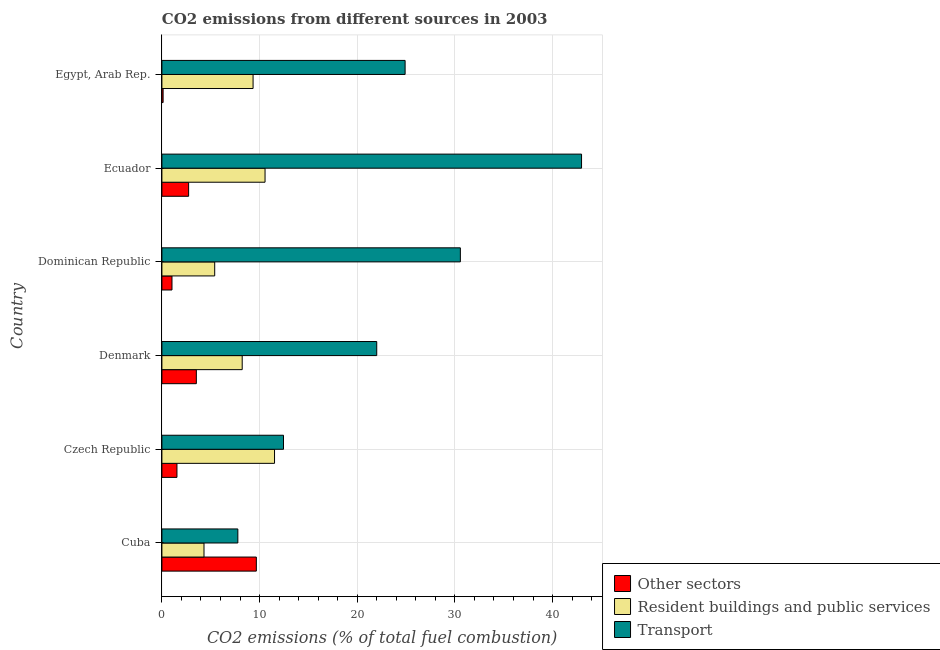How many different coloured bars are there?
Give a very brief answer. 3. Are the number of bars per tick equal to the number of legend labels?
Offer a terse response. Yes. Are the number of bars on each tick of the Y-axis equal?
Keep it short and to the point. Yes. How many bars are there on the 1st tick from the top?
Make the answer very short. 3. What is the label of the 2nd group of bars from the top?
Provide a short and direct response. Ecuador. In how many cases, is the number of bars for a given country not equal to the number of legend labels?
Provide a succinct answer. 0. What is the percentage of co2 emissions from transport in Cuba?
Keep it short and to the point. 7.78. Across all countries, what is the maximum percentage of co2 emissions from other sectors?
Offer a very short reply. 9.67. Across all countries, what is the minimum percentage of co2 emissions from other sectors?
Your answer should be compact. 0.12. In which country was the percentage of co2 emissions from resident buildings and public services maximum?
Your answer should be compact. Czech Republic. In which country was the percentage of co2 emissions from resident buildings and public services minimum?
Give a very brief answer. Cuba. What is the total percentage of co2 emissions from transport in the graph?
Ensure brevity in your answer.  140.65. What is the difference between the percentage of co2 emissions from resident buildings and public services in Czech Republic and that in Dominican Republic?
Keep it short and to the point. 6.12. What is the difference between the percentage of co2 emissions from resident buildings and public services in Czech Republic and the percentage of co2 emissions from other sectors in Cuba?
Offer a terse response. 1.86. What is the average percentage of co2 emissions from resident buildings and public services per country?
Your answer should be very brief. 8.23. What is the difference between the percentage of co2 emissions from resident buildings and public services and percentage of co2 emissions from transport in Cuba?
Provide a succinct answer. -3.46. In how many countries, is the percentage of co2 emissions from transport greater than 36 %?
Offer a terse response. 1. What is the ratio of the percentage of co2 emissions from transport in Czech Republic to that in Ecuador?
Your answer should be compact. 0.29. Is the percentage of co2 emissions from transport in Cuba less than that in Egypt, Arab Rep.?
Your response must be concise. Yes. What is the difference between the highest and the lowest percentage of co2 emissions from transport?
Keep it short and to the point. 35.19. In how many countries, is the percentage of co2 emissions from transport greater than the average percentage of co2 emissions from transport taken over all countries?
Make the answer very short. 3. Is the sum of the percentage of co2 emissions from transport in Denmark and Egypt, Arab Rep. greater than the maximum percentage of co2 emissions from resident buildings and public services across all countries?
Your response must be concise. Yes. What does the 1st bar from the top in Ecuador represents?
Make the answer very short. Transport. What does the 3rd bar from the bottom in Egypt, Arab Rep. represents?
Keep it short and to the point. Transport. Is it the case that in every country, the sum of the percentage of co2 emissions from other sectors and percentage of co2 emissions from resident buildings and public services is greater than the percentage of co2 emissions from transport?
Make the answer very short. No. Are all the bars in the graph horizontal?
Your answer should be very brief. Yes. How many countries are there in the graph?
Your answer should be compact. 6. Are the values on the major ticks of X-axis written in scientific E-notation?
Offer a very short reply. No. Does the graph contain any zero values?
Keep it short and to the point. No. Where does the legend appear in the graph?
Offer a terse response. Bottom right. How many legend labels are there?
Provide a short and direct response. 3. How are the legend labels stacked?
Offer a terse response. Vertical. What is the title of the graph?
Provide a short and direct response. CO2 emissions from different sources in 2003. What is the label or title of the X-axis?
Make the answer very short. CO2 emissions (% of total fuel combustion). What is the label or title of the Y-axis?
Provide a succinct answer. Country. What is the CO2 emissions (% of total fuel combustion) of Other sectors in Cuba?
Provide a short and direct response. 9.67. What is the CO2 emissions (% of total fuel combustion) of Resident buildings and public services in Cuba?
Ensure brevity in your answer.  4.31. What is the CO2 emissions (% of total fuel combustion) in Transport in Cuba?
Offer a terse response. 7.78. What is the CO2 emissions (% of total fuel combustion) of Other sectors in Czech Republic?
Provide a succinct answer. 1.54. What is the CO2 emissions (% of total fuel combustion) in Resident buildings and public services in Czech Republic?
Provide a short and direct response. 11.53. What is the CO2 emissions (% of total fuel combustion) in Transport in Czech Republic?
Make the answer very short. 12.45. What is the CO2 emissions (% of total fuel combustion) of Other sectors in Denmark?
Your response must be concise. 3.53. What is the CO2 emissions (% of total fuel combustion) of Resident buildings and public services in Denmark?
Provide a short and direct response. 8.22. What is the CO2 emissions (% of total fuel combustion) in Transport in Denmark?
Ensure brevity in your answer.  22. What is the CO2 emissions (% of total fuel combustion) in Other sectors in Dominican Republic?
Ensure brevity in your answer.  1.03. What is the CO2 emissions (% of total fuel combustion) in Resident buildings and public services in Dominican Republic?
Offer a very short reply. 5.41. What is the CO2 emissions (% of total fuel combustion) in Transport in Dominican Republic?
Your answer should be compact. 30.56. What is the CO2 emissions (% of total fuel combustion) in Other sectors in Ecuador?
Provide a succinct answer. 2.74. What is the CO2 emissions (% of total fuel combustion) in Resident buildings and public services in Ecuador?
Ensure brevity in your answer.  10.56. What is the CO2 emissions (% of total fuel combustion) in Transport in Ecuador?
Provide a succinct answer. 42.97. What is the CO2 emissions (% of total fuel combustion) in Other sectors in Egypt, Arab Rep.?
Offer a terse response. 0.12. What is the CO2 emissions (% of total fuel combustion) of Resident buildings and public services in Egypt, Arab Rep.?
Your answer should be compact. 9.33. What is the CO2 emissions (% of total fuel combustion) of Transport in Egypt, Arab Rep.?
Ensure brevity in your answer.  24.9. Across all countries, what is the maximum CO2 emissions (% of total fuel combustion) in Other sectors?
Provide a short and direct response. 9.67. Across all countries, what is the maximum CO2 emissions (% of total fuel combustion) in Resident buildings and public services?
Provide a short and direct response. 11.53. Across all countries, what is the maximum CO2 emissions (% of total fuel combustion) of Transport?
Your answer should be very brief. 42.97. Across all countries, what is the minimum CO2 emissions (% of total fuel combustion) in Other sectors?
Provide a short and direct response. 0.12. Across all countries, what is the minimum CO2 emissions (% of total fuel combustion) of Resident buildings and public services?
Your answer should be compact. 4.31. Across all countries, what is the minimum CO2 emissions (% of total fuel combustion) of Transport?
Make the answer very short. 7.78. What is the total CO2 emissions (% of total fuel combustion) of Other sectors in the graph?
Your answer should be compact. 18.63. What is the total CO2 emissions (% of total fuel combustion) of Resident buildings and public services in the graph?
Your answer should be compact. 49.37. What is the total CO2 emissions (% of total fuel combustion) of Transport in the graph?
Ensure brevity in your answer.  140.65. What is the difference between the CO2 emissions (% of total fuel combustion) in Other sectors in Cuba and that in Czech Republic?
Ensure brevity in your answer.  8.13. What is the difference between the CO2 emissions (% of total fuel combustion) of Resident buildings and public services in Cuba and that in Czech Republic?
Offer a terse response. -7.22. What is the difference between the CO2 emissions (% of total fuel combustion) of Transport in Cuba and that in Czech Republic?
Your answer should be compact. -4.67. What is the difference between the CO2 emissions (% of total fuel combustion) in Other sectors in Cuba and that in Denmark?
Give a very brief answer. 6.14. What is the difference between the CO2 emissions (% of total fuel combustion) in Resident buildings and public services in Cuba and that in Denmark?
Offer a terse response. -3.91. What is the difference between the CO2 emissions (% of total fuel combustion) in Transport in Cuba and that in Denmark?
Ensure brevity in your answer.  -14.22. What is the difference between the CO2 emissions (% of total fuel combustion) of Other sectors in Cuba and that in Dominican Republic?
Your response must be concise. 8.64. What is the difference between the CO2 emissions (% of total fuel combustion) in Resident buildings and public services in Cuba and that in Dominican Republic?
Provide a short and direct response. -1.1. What is the difference between the CO2 emissions (% of total fuel combustion) in Transport in Cuba and that in Dominican Republic?
Offer a terse response. -22.78. What is the difference between the CO2 emissions (% of total fuel combustion) of Other sectors in Cuba and that in Ecuador?
Keep it short and to the point. 6.93. What is the difference between the CO2 emissions (% of total fuel combustion) in Resident buildings and public services in Cuba and that in Ecuador?
Offer a very short reply. -6.25. What is the difference between the CO2 emissions (% of total fuel combustion) of Transport in Cuba and that in Ecuador?
Make the answer very short. -35.19. What is the difference between the CO2 emissions (% of total fuel combustion) in Other sectors in Cuba and that in Egypt, Arab Rep.?
Your answer should be compact. 9.55. What is the difference between the CO2 emissions (% of total fuel combustion) of Resident buildings and public services in Cuba and that in Egypt, Arab Rep.?
Provide a short and direct response. -5.02. What is the difference between the CO2 emissions (% of total fuel combustion) in Transport in Cuba and that in Egypt, Arab Rep.?
Give a very brief answer. -17.13. What is the difference between the CO2 emissions (% of total fuel combustion) of Other sectors in Czech Republic and that in Denmark?
Give a very brief answer. -1.99. What is the difference between the CO2 emissions (% of total fuel combustion) in Resident buildings and public services in Czech Republic and that in Denmark?
Your answer should be very brief. 3.31. What is the difference between the CO2 emissions (% of total fuel combustion) of Transport in Czech Republic and that in Denmark?
Ensure brevity in your answer.  -9.55. What is the difference between the CO2 emissions (% of total fuel combustion) of Other sectors in Czech Republic and that in Dominican Republic?
Provide a short and direct response. 0.51. What is the difference between the CO2 emissions (% of total fuel combustion) of Resident buildings and public services in Czech Republic and that in Dominican Republic?
Give a very brief answer. 6.12. What is the difference between the CO2 emissions (% of total fuel combustion) of Transport in Czech Republic and that in Dominican Republic?
Your answer should be compact. -18.11. What is the difference between the CO2 emissions (% of total fuel combustion) in Other sectors in Czech Republic and that in Ecuador?
Ensure brevity in your answer.  -1.2. What is the difference between the CO2 emissions (% of total fuel combustion) in Resident buildings and public services in Czech Republic and that in Ecuador?
Keep it short and to the point. 0.97. What is the difference between the CO2 emissions (% of total fuel combustion) of Transport in Czech Republic and that in Ecuador?
Make the answer very short. -30.52. What is the difference between the CO2 emissions (% of total fuel combustion) of Other sectors in Czech Republic and that in Egypt, Arab Rep.?
Keep it short and to the point. 1.42. What is the difference between the CO2 emissions (% of total fuel combustion) in Resident buildings and public services in Czech Republic and that in Egypt, Arab Rep.?
Give a very brief answer. 2.2. What is the difference between the CO2 emissions (% of total fuel combustion) in Transport in Czech Republic and that in Egypt, Arab Rep.?
Offer a very short reply. -12.45. What is the difference between the CO2 emissions (% of total fuel combustion) of Other sectors in Denmark and that in Dominican Republic?
Your answer should be compact. 2.49. What is the difference between the CO2 emissions (% of total fuel combustion) of Resident buildings and public services in Denmark and that in Dominican Republic?
Give a very brief answer. 2.82. What is the difference between the CO2 emissions (% of total fuel combustion) in Transport in Denmark and that in Dominican Republic?
Keep it short and to the point. -8.56. What is the difference between the CO2 emissions (% of total fuel combustion) of Other sectors in Denmark and that in Ecuador?
Ensure brevity in your answer.  0.79. What is the difference between the CO2 emissions (% of total fuel combustion) of Resident buildings and public services in Denmark and that in Ecuador?
Offer a very short reply. -2.34. What is the difference between the CO2 emissions (% of total fuel combustion) in Transport in Denmark and that in Ecuador?
Your answer should be very brief. -20.97. What is the difference between the CO2 emissions (% of total fuel combustion) in Other sectors in Denmark and that in Egypt, Arab Rep.?
Your answer should be very brief. 3.4. What is the difference between the CO2 emissions (% of total fuel combustion) of Resident buildings and public services in Denmark and that in Egypt, Arab Rep.?
Offer a very short reply. -1.11. What is the difference between the CO2 emissions (% of total fuel combustion) of Transport in Denmark and that in Egypt, Arab Rep.?
Offer a very short reply. -2.9. What is the difference between the CO2 emissions (% of total fuel combustion) in Other sectors in Dominican Republic and that in Ecuador?
Your answer should be very brief. -1.7. What is the difference between the CO2 emissions (% of total fuel combustion) of Resident buildings and public services in Dominican Republic and that in Ecuador?
Your response must be concise. -5.15. What is the difference between the CO2 emissions (% of total fuel combustion) of Transport in Dominican Republic and that in Ecuador?
Offer a very short reply. -12.41. What is the difference between the CO2 emissions (% of total fuel combustion) of Other sectors in Dominican Republic and that in Egypt, Arab Rep.?
Your answer should be very brief. 0.91. What is the difference between the CO2 emissions (% of total fuel combustion) in Resident buildings and public services in Dominican Republic and that in Egypt, Arab Rep.?
Your response must be concise. -3.93. What is the difference between the CO2 emissions (% of total fuel combustion) of Transport in Dominican Republic and that in Egypt, Arab Rep.?
Your answer should be very brief. 5.66. What is the difference between the CO2 emissions (% of total fuel combustion) of Other sectors in Ecuador and that in Egypt, Arab Rep.?
Make the answer very short. 2.61. What is the difference between the CO2 emissions (% of total fuel combustion) in Resident buildings and public services in Ecuador and that in Egypt, Arab Rep.?
Provide a succinct answer. 1.23. What is the difference between the CO2 emissions (% of total fuel combustion) of Transport in Ecuador and that in Egypt, Arab Rep.?
Give a very brief answer. 18.07. What is the difference between the CO2 emissions (% of total fuel combustion) in Other sectors in Cuba and the CO2 emissions (% of total fuel combustion) in Resident buildings and public services in Czech Republic?
Your response must be concise. -1.86. What is the difference between the CO2 emissions (% of total fuel combustion) in Other sectors in Cuba and the CO2 emissions (% of total fuel combustion) in Transport in Czech Republic?
Provide a short and direct response. -2.78. What is the difference between the CO2 emissions (% of total fuel combustion) of Resident buildings and public services in Cuba and the CO2 emissions (% of total fuel combustion) of Transport in Czech Republic?
Your answer should be very brief. -8.14. What is the difference between the CO2 emissions (% of total fuel combustion) in Other sectors in Cuba and the CO2 emissions (% of total fuel combustion) in Resident buildings and public services in Denmark?
Your response must be concise. 1.45. What is the difference between the CO2 emissions (% of total fuel combustion) in Other sectors in Cuba and the CO2 emissions (% of total fuel combustion) in Transport in Denmark?
Make the answer very short. -12.33. What is the difference between the CO2 emissions (% of total fuel combustion) in Resident buildings and public services in Cuba and the CO2 emissions (% of total fuel combustion) in Transport in Denmark?
Your answer should be very brief. -17.69. What is the difference between the CO2 emissions (% of total fuel combustion) of Other sectors in Cuba and the CO2 emissions (% of total fuel combustion) of Resident buildings and public services in Dominican Republic?
Provide a succinct answer. 4.26. What is the difference between the CO2 emissions (% of total fuel combustion) in Other sectors in Cuba and the CO2 emissions (% of total fuel combustion) in Transport in Dominican Republic?
Provide a succinct answer. -20.89. What is the difference between the CO2 emissions (% of total fuel combustion) of Resident buildings and public services in Cuba and the CO2 emissions (% of total fuel combustion) of Transport in Dominican Republic?
Provide a short and direct response. -26.25. What is the difference between the CO2 emissions (% of total fuel combustion) in Other sectors in Cuba and the CO2 emissions (% of total fuel combustion) in Resident buildings and public services in Ecuador?
Offer a terse response. -0.89. What is the difference between the CO2 emissions (% of total fuel combustion) of Other sectors in Cuba and the CO2 emissions (% of total fuel combustion) of Transport in Ecuador?
Keep it short and to the point. -33.3. What is the difference between the CO2 emissions (% of total fuel combustion) in Resident buildings and public services in Cuba and the CO2 emissions (% of total fuel combustion) in Transport in Ecuador?
Your response must be concise. -38.66. What is the difference between the CO2 emissions (% of total fuel combustion) of Other sectors in Cuba and the CO2 emissions (% of total fuel combustion) of Resident buildings and public services in Egypt, Arab Rep.?
Make the answer very short. 0.33. What is the difference between the CO2 emissions (% of total fuel combustion) in Other sectors in Cuba and the CO2 emissions (% of total fuel combustion) in Transport in Egypt, Arab Rep.?
Provide a succinct answer. -15.23. What is the difference between the CO2 emissions (% of total fuel combustion) of Resident buildings and public services in Cuba and the CO2 emissions (% of total fuel combustion) of Transport in Egypt, Arab Rep.?
Ensure brevity in your answer.  -20.59. What is the difference between the CO2 emissions (% of total fuel combustion) in Other sectors in Czech Republic and the CO2 emissions (% of total fuel combustion) in Resident buildings and public services in Denmark?
Provide a short and direct response. -6.68. What is the difference between the CO2 emissions (% of total fuel combustion) of Other sectors in Czech Republic and the CO2 emissions (% of total fuel combustion) of Transport in Denmark?
Your answer should be very brief. -20.46. What is the difference between the CO2 emissions (% of total fuel combustion) of Resident buildings and public services in Czech Republic and the CO2 emissions (% of total fuel combustion) of Transport in Denmark?
Your answer should be very brief. -10.47. What is the difference between the CO2 emissions (% of total fuel combustion) in Other sectors in Czech Republic and the CO2 emissions (% of total fuel combustion) in Resident buildings and public services in Dominican Republic?
Your answer should be very brief. -3.87. What is the difference between the CO2 emissions (% of total fuel combustion) of Other sectors in Czech Republic and the CO2 emissions (% of total fuel combustion) of Transport in Dominican Republic?
Provide a short and direct response. -29.02. What is the difference between the CO2 emissions (% of total fuel combustion) in Resident buildings and public services in Czech Republic and the CO2 emissions (% of total fuel combustion) in Transport in Dominican Republic?
Keep it short and to the point. -19.03. What is the difference between the CO2 emissions (% of total fuel combustion) in Other sectors in Czech Republic and the CO2 emissions (% of total fuel combustion) in Resident buildings and public services in Ecuador?
Offer a terse response. -9.02. What is the difference between the CO2 emissions (% of total fuel combustion) in Other sectors in Czech Republic and the CO2 emissions (% of total fuel combustion) in Transport in Ecuador?
Make the answer very short. -41.43. What is the difference between the CO2 emissions (% of total fuel combustion) in Resident buildings and public services in Czech Republic and the CO2 emissions (% of total fuel combustion) in Transport in Ecuador?
Offer a very short reply. -31.43. What is the difference between the CO2 emissions (% of total fuel combustion) in Other sectors in Czech Republic and the CO2 emissions (% of total fuel combustion) in Resident buildings and public services in Egypt, Arab Rep.?
Your response must be concise. -7.79. What is the difference between the CO2 emissions (% of total fuel combustion) of Other sectors in Czech Republic and the CO2 emissions (% of total fuel combustion) of Transport in Egypt, Arab Rep.?
Your answer should be very brief. -23.36. What is the difference between the CO2 emissions (% of total fuel combustion) of Resident buildings and public services in Czech Republic and the CO2 emissions (% of total fuel combustion) of Transport in Egypt, Arab Rep.?
Your answer should be compact. -13.37. What is the difference between the CO2 emissions (% of total fuel combustion) in Other sectors in Denmark and the CO2 emissions (% of total fuel combustion) in Resident buildings and public services in Dominican Republic?
Ensure brevity in your answer.  -1.88. What is the difference between the CO2 emissions (% of total fuel combustion) of Other sectors in Denmark and the CO2 emissions (% of total fuel combustion) of Transport in Dominican Republic?
Make the answer very short. -27.03. What is the difference between the CO2 emissions (% of total fuel combustion) in Resident buildings and public services in Denmark and the CO2 emissions (% of total fuel combustion) in Transport in Dominican Republic?
Provide a succinct answer. -22.34. What is the difference between the CO2 emissions (% of total fuel combustion) of Other sectors in Denmark and the CO2 emissions (% of total fuel combustion) of Resident buildings and public services in Ecuador?
Your answer should be compact. -7.04. What is the difference between the CO2 emissions (% of total fuel combustion) in Other sectors in Denmark and the CO2 emissions (% of total fuel combustion) in Transport in Ecuador?
Offer a very short reply. -39.44. What is the difference between the CO2 emissions (% of total fuel combustion) in Resident buildings and public services in Denmark and the CO2 emissions (% of total fuel combustion) in Transport in Ecuador?
Provide a short and direct response. -34.74. What is the difference between the CO2 emissions (% of total fuel combustion) in Other sectors in Denmark and the CO2 emissions (% of total fuel combustion) in Resident buildings and public services in Egypt, Arab Rep.?
Offer a terse response. -5.81. What is the difference between the CO2 emissions (% of total fuel combustion) of Other sectors in Denmark and the CO2 emissions (% of total fuel combustion) of Transport in Egypt, Arab Rep.?
Offer a terse response. -21.37. What is the difference between the CO2 emissions (% of total fuel combustion) in Resident buildings and public services in Denmark and the CO2 emissions (% of total fuel combustion) in Transport in Egypt, Arab Rep.?
Make the answer very short. -16.68. What is the difference between the CO2 emissions (% of total fuel combustion) in Other sectors in Dominican Republic and the CO2 emissions (% of total fuel combustion) in Resident buildings and public services in Ecuador?
Your response must be concise. -9.53. What is the difference between the CO2 emissions (% of total fuel combustion) of Other sectors in Dominican Republic and the CO2 emissions (% of total fuel combustion) of Transport in Ecuador?
Keep it short and to the point. -41.93. What is the difference between the CO2 emissions (% of total fuel combustion) in Resident buildings and public services in Dominican Republic and the CO2 emissions (% of total fuel combustion) in Transport in Ecuador?
Provide a succinct answer. -37.56. What is the difference between the CO2 emissions (% of total fuel combustion) of Other sectors in Dominican Republic and the CO2 emissions (% of total fuel combustion) of Resident buildings and public services in Egypt, Arab Rep.?
Provide a short and direct response. -8.3. What is the difference between the CO2 emissions (% of total fuel combustion) of Other sectors in Dominican Republic and the CO2 emissions (% of total fuel combustion) of Transport in Egypt, Arab Rep.?
Provide a succinct answer. -23.87. What is the difference between the CO2 emissions (% of total fuel combustion) of Resident buildings and public services in Dominican Republic and the CO2 emissions (% of total fuel combustion) of Transport in Egypt, Arab Rep.?
Offer a terse response. -19.49. What is the difference between the CO2 emissions (% of total fuel combustion) of Other sectors in Ecuador and the CO2 emissions (% of total fuel combustion) of Resident buildings and public services in Egypt, Arab Rep.?
Your answer should be very brief. -6.6. What is the difference between the CO2 emissions (% of total fuel combustion) in Other sectors in Ecuador and the CO2 emissions (% of total fuel combustion) in Transport in Egypt, Arab Rep.?
Offer a very short reply. -22.16. What is the difference between the CO2 emissions (% of total fuel combustion) of Resident buildings and public services in Ecuador and the CO2 emissions (% of total fuel combustion) of Transport in Egypt, Arab Rep.?
Your answer should be very brief. -14.34. What is the average CO2 emissions (% of total fuel combustion) of Other sectors per country?
Provide a short and direct response. 3.1. What is the average CO2 emissions (% of total fuel combustion) of Resident buildings and public services per country?
Your answer should be compact. 8.23. What is the average CO2 emissions (% of total fuel combustion) in Transport per country?
Ensure brevity in your answer.  23.44. What is the difference between the CO2 emissions (% of total fuel combustion) of Other sectors and CO2 emissions (% of total fuel combustion) of Resident buildings and public services in Cuba?
Offer a very short reply. 5.36. What is the difference between the CO2 emissions (% of total fuel combustion) in Other sectors and CO2 emissions (% of total fuel combustion) in Transport in Cuba?
Your answer should be very brief. 1.89. What is the difference between the CO2 emissions (% of total fuel combustion) in Resident buildings and public services and CO2 emissions (% of total fuel combustion) in Transport in Cuba?
Your response must be concise. -3.46. What is the difference between the CO2 emissions (% of total fuel combustion) of Other sectors and CO2 emissions (% of total fuel combustion) of Resident buildings and public services in Czech Republic?
Your answer should be very brief. -9.99. What is the difference between the CO2 emissions (% of total fuel combustion) of Other sectors and CO2 emissions (% of total fuel combustion) of Transport in Czech Republic?
Ensure brevity in your answer.  -10.91. What is the difference between the CO2 emissions (% of total fuel combustion) of Resident buildings and public services and CO2 emissions (% of total fuel combustion) of Transport in Czech Republic?
Your response must be concise. -0.92. What is the difference between the CO2 emissions (% of total fuel combustion) of Other sectors and CO2 emissions (% of total fuel combustion) of Resident buildings and public services in Denmark?
Offer a very short reply. -4.7. What is the difference between the CO2 emissions (% of total fuel combustion) of Other sectors and CO2 emissions (% of total fuel combustion) of Transport in Denmark?
Provide a succinct answer. -18.47. What is the difference between the CO2 emissions (% of total fuel combustion) of Resident buildings and public services and CO2 emissions (% of total fuel combustion) of Transport in Denmark?
Your answer should be compact. -13.77. What is the difference between the CO2 emissions (% of total fuel combustion) in Other sectors and CO2 emissions (% of total fuel combustion) in Resident buildings and public services in Dominican Republic?
Offer a terse response. -4.37. What is the difference between the CO2 emissions (% of total fuel combustion) in Other sectors and CO2 emissions (% of total fuel combustion) in Transport in Dominican Republic?
Give a very brief answer. -29.53. What is the difference between the CO2 emissions (% of total fuel combustion) of Resident buildings and public services and CO2 emissions (% of total fuel combustion) of Transport in Dominican Republic?
Your answer should be compact. -25.15. What is the difference between the CO2 emissions (% of total fuel combustion) in Other sectors and CO2 emissions (% of total fuel combustion) in Resident buildings and public services in Ecuador?
Give a very brief answer. -7.83. What is the difference between the CO2 emissions (% of total fuel combustion) in Other sectors and CO2 emissions (% of total fuel combustion) in Transport in Ecuador?
Your answer should be very brief. -40.23. What is the difference between the CO2 emissions (% of total fuel combustion) of Resident buildings and public services and CO2 emissions (% of total fuel combustion) of Transport in Ecuador?
Your answer should be very brief. -32.41. What is the difference between the CO2 emissions (% of total fuel combustion) of Other sectors and CO2 emissions (% of total fuel combustion) of Resident buildings and public services in Egypt, Arab Rep.?
Give a very brief answer. -9.21. What is the difference between the CO2 emissions (% of total fuel combustion) in Other sectors and CO2 emissions (% of total fuel combustion) in Transport in Egypt, Arab Rep.?
Keep it short and to the point. -24.78. What is the difference between the CO2 emissions (% of total fuel combustion) of Resident buildings and public services and CO2 emissions (% of total fuel combustion) of Transport in Egypt, Arab Rep.?
Provide a short and direct response. -15.57. What is the ratio of the CO2 emissions (% of total fuel combustion) in Other sectors in Cuba to that in Czech Republic?
Provide a short and direct response. 6.28. What is the ratio of the CO2 emissions (% of total fuel combustion) in Resident buildings and public services in Cuba to that in Czech Republic?
Provide a short and direct response. 0.37. What is the ratio of the CO2 emissions (% of total fuel combustion) of Transport in Cuba to that in Czech Republic?
Give a very brief answer. 0.62. What is the ratio of the CO2 emissions (% of total fuel combustion) in Other sectors in Cuba to that in Denmark?
Your answer should be very brief. 2.74. What is the ratio of the CO2 emissions (% of total fuel combustion) of Resident buildings and public services in Cuba to that in Denmark?
Offer a very short reply. 0.52. What is the ratio of the CO2 emissions (% of total fuel combustion) in Transport in Cuba to that in Denmark?
Your answer should be very brief. 0.35. What is the ratio of the CO2 emissions (% of total fuel combustion) in Other sectors in Cuba to that in Dominican Republic?
Keep it short and to the point. 9.36. What is the ratio of the CO2 emissions (% of total fuel combustion) of Resident buildings and public services in Cuba to that in Dominican Republic?
Provide a short and direct response. 0.8. What is the ratio of the CO2 emissions (% of total fuel combustion) in Transport in Cuba to that in Dominican Republic?
Offer a terse response. 0.25. What is the ratio of the CO2 emissions (% of total fuel combustion) of Other sectors in Cuba to that in Ecuador?
Give a very brief answer. 3.53. What is the ratio of the CO2 emissions (% of total fuel combustion) of Resident buildings and public services in Cuba to that in Ecuador?
Your response must be concise. 0.41. What is the ratio of the CO2 emissions (% of total fuel combustion) of Transport in Cuba to that in Ecuador?
Ensure brevity in your answer.  0.18. What is the ratio of the CO2 emissions (% of total fuel combustion) of Other sectors in Cuba to that in Egypt, Arab Rep.?
Provide a short and direct response. 78.52. What is the ratio of the CO2 emissions (% of total fuel combustion) of Resident buildings and public services in Cuba to that in Egypt, Arab Rep.?
Ensure brevity in your answer.  0.46. What is the ratio of the CO2 emissions (% of total fuel combustion) of Transport in Cuba to that in Egypt, Arab Rep.?
Make the answer very short. 0.31. What is the ratio of the CO2 emissions (% of total fuel combustion) in Other sectors in Czech Republic to that in Denmark?
Provide a succinct answer. 0.44. What is the ratio of the CO2 emissions (% of total fuel combustion) of Resident buildings and public services in Czech Republic to that in Denmark?
Make the answer very short. 1.4. What is the ratio of the CO2 emissions (% of total fuel combustion) in Transport in Czech Republic to that in Denmark?
Keep it short and to the point. 0.57. What is the ratio of the CO2 emissions (% of total fuel combustion) of Other sectors in Czech Republic to that in Dominican Republic?
Your answer should be compact. 1.49. What is the ratio of the CO2 emissions (% of total fuel combustion) of Resident buildings and public services in Czech Republic to that in Dominican Republic?
Ensure brevity in your answer.  2.13. What is the ratio of the CO2 emissions (% of total fuel combustion) of Transport in Czech Republic to that in Dominican Republic?
Your response must be concise. 0.41. What is the ratio of the CO2 emissions (% of total fuel combustion) of Other sectors in Czech Republic to that in Ecuador?
Provide a succinct answer. 0.56. What is the ratio of the CO2 emissions (% of total fuel combustion) of Resident buildings and public services in Czech Republic to that in Ecuador?
Make the answer very short. 1.09. What is the ratio of the CO2 emissions (% of total fuel combustion) in Transport in Czech Republic to that in Ecuador?
Provide a short and direct response. 0.29. What is the ratio of the CO2 emissions (% of total fuel combustion) in Other sectors in Czech Republic to that in Egypt, Arab Rep.?
Provide a succinct answer. 12.51. What is the ratio of the CO2 emissions (% of total fuel combustion) in Resident buildings and public services in Czech Republic to that in Egypt, Arab Rep.?
Offer a terse response. 1.24. What is the ratio of the CO2 emissions (% of total fuel combustion) of Transport in Czech Republic to that in Egypt, Arab Rep.?
Keep it short and to the point. 0.5. What is the ratio of the CO2 emissions (% of total fuel combustion) of Other sectors in Denmark to that in Dominican Republic?
Your response must be concise. 3.41. What is the ratio of the CO2 emissions (% of total fuel combustion) in Resident buildings and public services in Denmark to that in Dominican Republic?
Your answer should be very brief. 1.52. What is the ratio of the CO2 emissions (% of total fuel combustion) of Transport in Denmark to that in Dominican Republic?
Ensure brevity in your answer.  0.72. What is the ratio of the CO2 emissions (% of total fuel combustion) of Other sectors in Denmark to that in Ecuador?
Offer a very short reply. 1.29. What is the ratio of the CO2 emissions (% of total fuel combustion) in Resident buildings and public services in Denmark to that in Ecuador?
Provide a short and direct response. 0.78. What is the ratio of the CO2 emissions (% of total fuel combustion) of Transport in Denmark to that in Ecuador?
Your response must be concise. 0.51. What is the ratio of the CO2 emissions (% of total fuel combustion) of Other sectors in Denmark to that in Egypt, Arab Rep.?
Your answer should be very brief. 28.64. What is the ratio of the CO2 emissions (% of total fuel combustion) in Resident buildings and public services in Denmark to that in Egypt, Arab Rep.?
Ensure brevity in your answer.  0.88. What is the ratio of the CO2 emissions (% of total fuel combustion) of Transport in Denmark to that in Egypt, Arab Rep.?
Your answer should be compact. 0.88. What is the ratio of the CO2 emissions (% of total fuel combustion) in Other sectors in Dominican Republic to that in Ecuador?
Give a very brief answer. 0.38. What is the ratio of the CO2 emissions (% of total fuel combustion) of Resident buildings and public services in Dominican Republic to that in Ecuador?
Your answer should be very brief. 0.51. What is the ratio of the CO2 emissions (% of total fuel combustion) in Transport in Dominican Republic to that in Ecuador?
Make the answer very short. 0.71. What is the ratio of the CO2 emissions (% of total fuel combustion) of Other sectors in Dominican Republic to that in Egypt, Arab Rep.?
Provide a short and direct response. 8.39. What is the ratio of the CO2 emissions (% of total fuel combustion) in Resident buildings and public services in Dominican Republic to that in Egypt, Arab Rep.?
Your response must be concise. 0.58. What is the ratio of the CO2 emissions (% of total fuel combustion) in Transport in Dominican Republic to that in Egypt, Arab Rep.?
Give a very brief answer. 1.23. What is the ratio of the CO2 emissions (% of total fuel combustion) in Other sectors in Ecuador to that in Egypt, Arab Rep.?
Offer a very short reply. 22.22. What is the ratio of the CO2 emissions (% of total fuel combustion) of Resident buildings and public services in Ecuador to that in Egypt, Arab Rep.?
Provide a short and direct response. 1.13. What is the ratio of the CO2 emissions (% of total fuel combustion) in Transport in Ecuador to that in Egypt, Arab Rep.?
Your answer should be compact. 1.73. What is the difference between the highest and the second highest CO2 emissions (% of total fuel combustion) of Other sectors?
Provide a succinct answer. 6.14. What is the difference between the highest and the second highest CO2 emissions (% of total fuel combustion) in Resident buildings and public services?
Make the answer very short. 0.97. What is the difference between the highest and the second highest CO2 emissions (% of total fuel combustion) in Transport?
Provide a succinct answer. 12.41. What is the difference between the highest and the lowest CO2 emissions (% of total fuel combustion) in Other sectors?
Give a very brief answer. 9.55. What is the difference between the highest and the lowest CO2 emissions (% of total fuel combustion) of Resident buildings and public services?
Keep it short and to the point. 7.22. What is the difference between the highest and the lowest CO2 emissions (% of total fuel combustion) of Transport?
Offer a terse response. 35.19. 